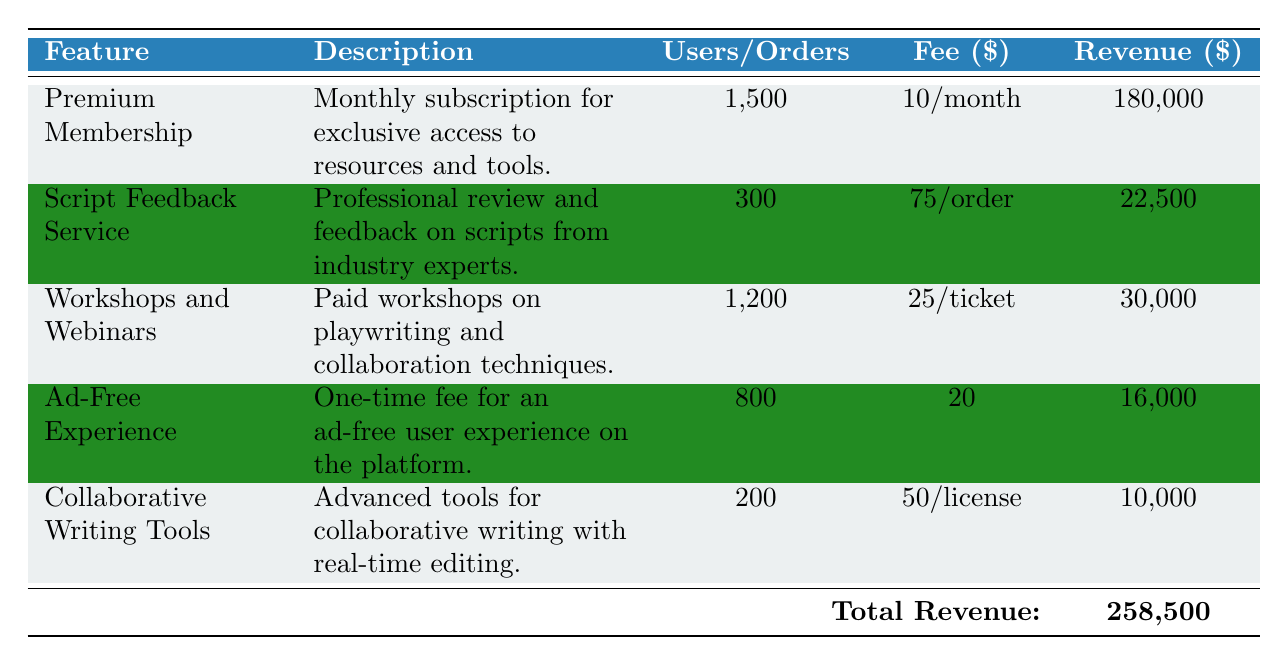What is the total revenue generated from all premium features in 2022? The total revenue is provided at the bottom of the table, which states that the total revenue is 240,500.
Answer: 240,500 How many subscribers are there for the Premium Membership feature? The number of subscribers is listed in the Premium Membership row, which states that there are 1,500 subscribers.
Answer: 1,500 What is the fee for the Script Feedback Service? In the Script Feedback Service row, it shows that the fee per order is 75.
Answer: 75 Is the revenue generated from Workshops and Webinars higher than that from the Ad-Free Experience? The total revenue for Workshops and Webinars is 30,000 and for Ad-Free Experience is 16,000. Since 30,000 is greater than 16,000, the answer is yes.
Answer: Yes What is the difference in total revenue between the Premium Membership and Collaborative Writing Tools? The revenue for Premium Membership is 180,000 and for Collaborative Writing Tools is 10,000. The difference is calculated as 180,000 - 10,000 = 170,000.
Answer: 170,000 How many total attendees participated in Workshops and Webinars? The table indicates that the total number of attendees for Workshops and Webinars is 1,200.
Answer: 1,200 Is it true that there are more total orders for the Script Feedback Service than total licenses sold for Collaborative Writing Tools? The table shows there are 300 total orders for Script Feedback Service and 200 total licenses sold for Collaborative Writing Tools, confirming that 300 is greater than 200. Therefore, the statement is true.
Answer: True What is the average revenue generated per subscriber in the Premium Membership? The Premium Membership total revenue is 180,000 and there are 1,500 subscribers. The average revenue per subscriber is calculated as 180,000 / 1,500 = 120.
Answer: 120 How much revenue was generated from the Ad-Free Experience? The total revenue from the Ad-Free Experience feature is given in the corresponding row, showing it is 16,000.
Answer: 16,000 